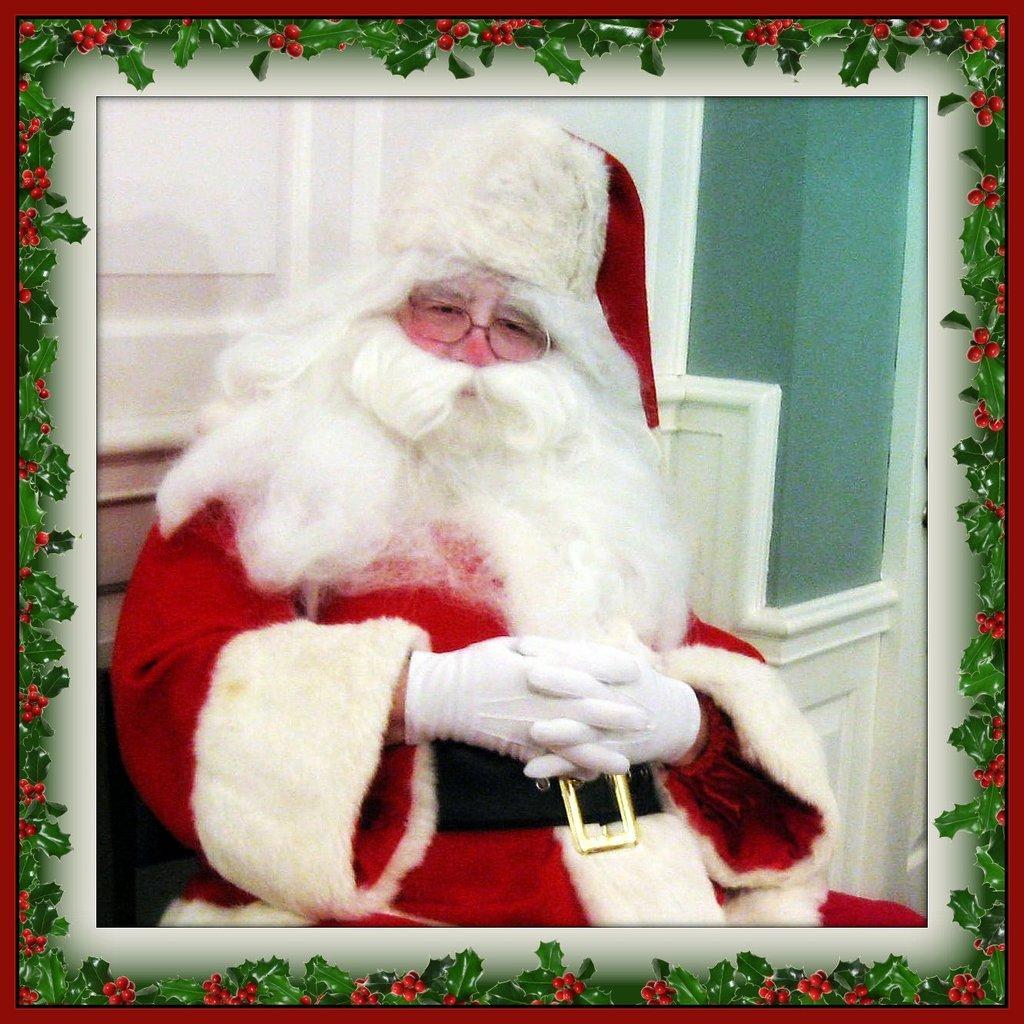Describe this image in one or two sentences. In this image we can see one picture of a Santa Claus with spectacles sitting near the white door, there is the red border with green leaves and red fruits. 